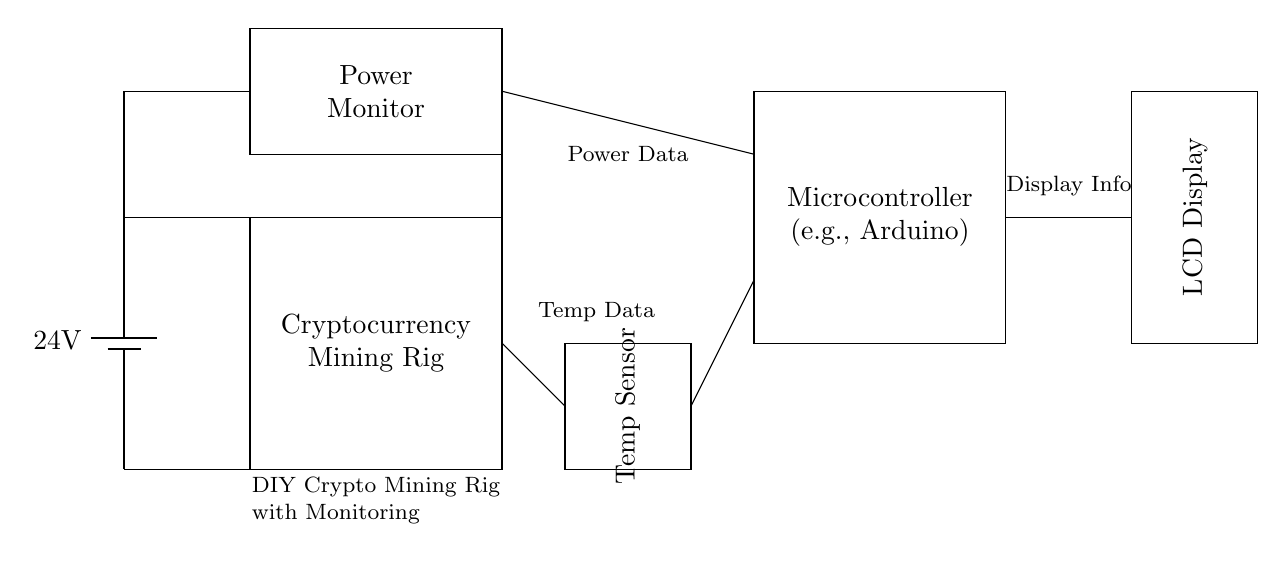What is the power supply voltage? The power supply is indicated as a battery with a label showing 24 volts. Thus, the voltage is derived directly from the battery component in the diagram.
Answer: 24 volts What does the rectangle labeled with "Temp Sensor" represent? The rectangle labeled "Temp Sensor" in the diagram indicates the component responsible for measuring temperature. It is specifically denoted as a temperature sensor, confirming its purpose.
Answer: Temperature sensor How many main components are shown in the circuit? By counting the distinct labeled components, we identify the power supply, mining rig, power monitor, temperature sensor, microcontroller, and display. There are a total of six components present in the circuit.
Answer: Six Which component is connected to the LCD display? The microcontroller is indicated in the circuit and appears to have a direct line connecting through to the LCD Display. Thus, it is responsible for sending data to that display.
Answer: Microcontroller What type of information does the "Power Monitor" provide? The "Power Monitor" is labeled to suggest that it provides data concerning the power consumption of the mining rig. This is inferred from both the label of the component and its positioning relative to the mining rig.
Answer: Power consumption data How is the temperature data routed to the microcontroller? The diagram shows a direct line connecting the temperature sensor to the microcontroller, indicating that temperature data from the sensor is sent straight to the microcontroller for processing. Therefore, the routing can be traced directly through the connection lines.
Answer: Directly via a connection line 